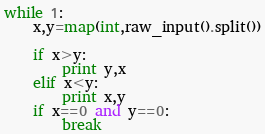Convert code to text. <code><loc_0><loc_0><loc_500><loc_500><_Python_>while 1:
    x,y=map(int,raw_input().split())

    if x>y:
        print y,x
    elif x<y:
        print x,y
    if x==0 and y==0:
        break</code> 